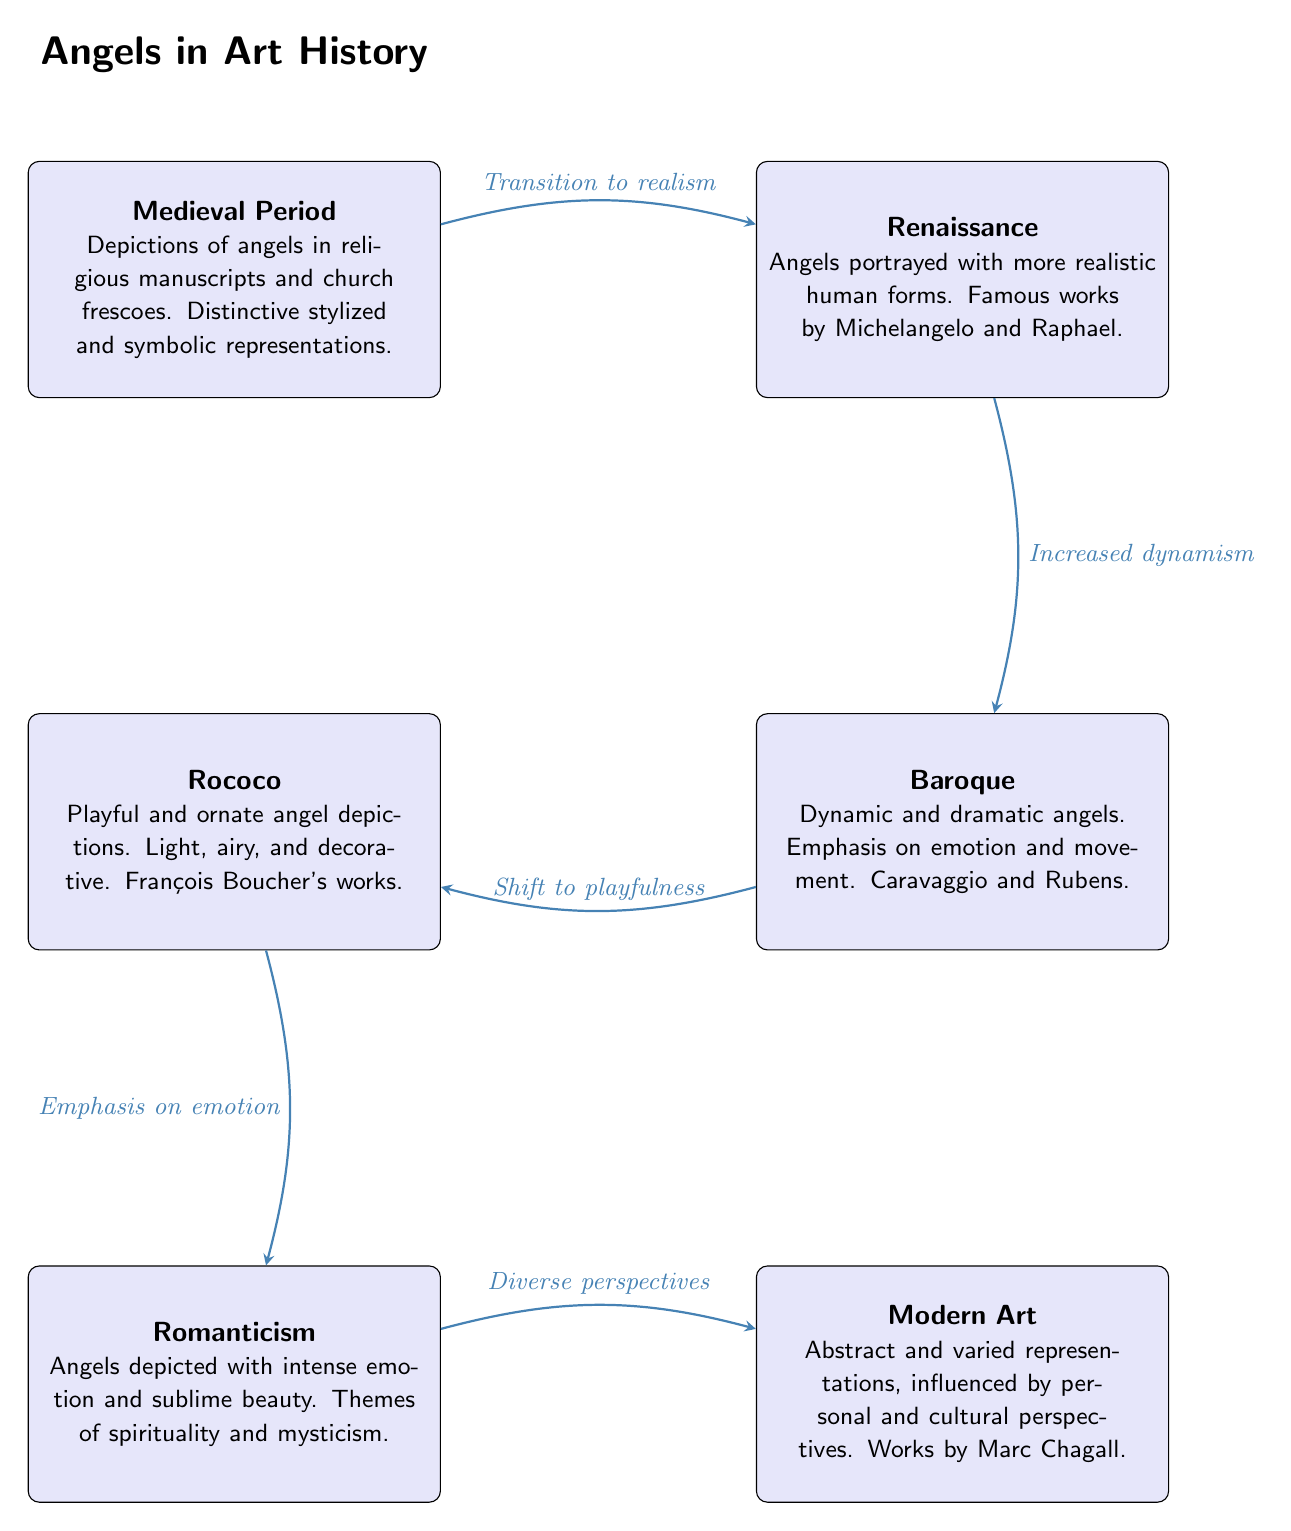What are the two art movements directly connected to the Medieval Period? The Medieval Period is connected to the Renaissance, as indicated by an arrow leading directly to it. Additionally, there is no direct connection to another movement, making the Renaissance the only answer.
Answer: Renaissance Which artist is associated with the Baroque period's depiction of angels? The Baroque period mentions Caravaggio and Rubens as prominent artists known for their dynamic and dramatic depictions of angels. Therefore, either of those names could be correct, but since the question asks for one, we will choose Caravaggio as it is listed first.
Answer: Caravaggio How many art movements are represented in the diagram? The diagram outlines five distinct art movements: Medieval, Renaissance, Baroque, Rococo, Romanticism, and Modern Art. To determine this, we can physically count the nodes or recognize each movement mentioned.
Answer: 6 What is the transition described between Rococo and Romanticism? The arrow from Rococo to Romanticism indicates that the transition emphasized emotion, suggesting a shift from a light and playful depiction of angels to one that highlights intense emotions and spirituality in Romanticism.
Answer: Emphasis on emotion Which period introduced realism in angel depictions? The connection from the Medieval Period to the Renaissance states it was a transition to realism, showcasing the shift in how angels were depicted during this time. Thus, Renaissance is the period where realism was introduced in the depiction of angels.
Answer: Renaissance What stylistic emphasis is noted in Modern Art for angel representations? The diagram outlines a shift in Modern Art toward abstract and varied representations of angels, influenced by personal and cultural perspectives. This stylistic emphasis reflects a deviation from traditional forms into subjective interpretations.
Answer: Abstract and varied representations 